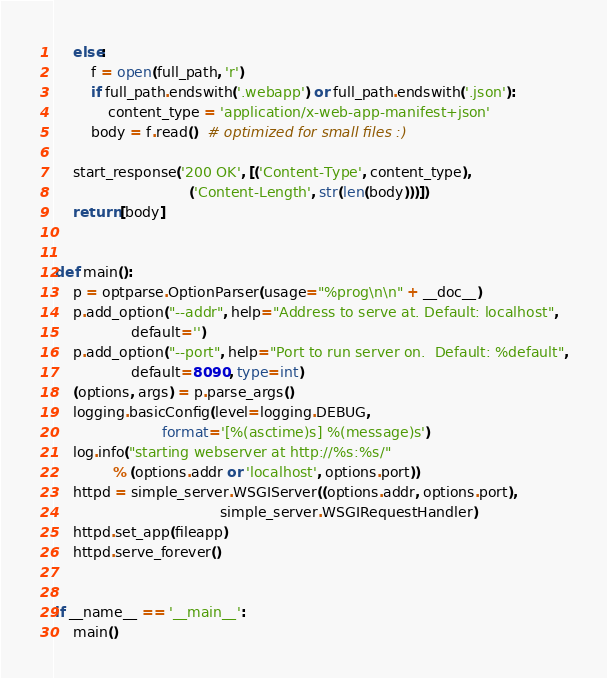Convert code to text. <code><loc_0><loc_0><loc_500><loc_500><_Python_>    else:
        f = open(full_path, 'r')
        if full_path.endswith('.webapp') or full_path.endswith('.json'):
            content_type = 'application/x-web-app-manifest+json'
        body = f.read()  # optimized for small files :)

    start_response('200 OK', [('Content-Type', content_type),
                              ('Content-Length', str(len(body)))])
    return [body]


def main():
    p = optparse.OptionParser(usage="%prog\n\n" + __doc__)
    p.add_option("--addr", help="Address to serve at. Default: localhost",
                 default='')
    p.add_option("--port", help="Port to run server on.  Default: %default",
                 default=8090, type=int)
    (options, args) = p.parse_args()
    logging.basicConfig(level=logging.DEBUG,
                        format='[%(asctime)s] %(message)s')
    log.info("starting webserver at http://%s:%s/"
             % (options.addr or 'localhost', options.port))
    httpd = simple_server.WSGIServer((options.addr, options.port),
                                     simple_server.WSGIRequestHandler)
    httpd.set_app(fileapp)
    httpd.serve_forever()


if __name__ == '__main__':
    main()
</code> 